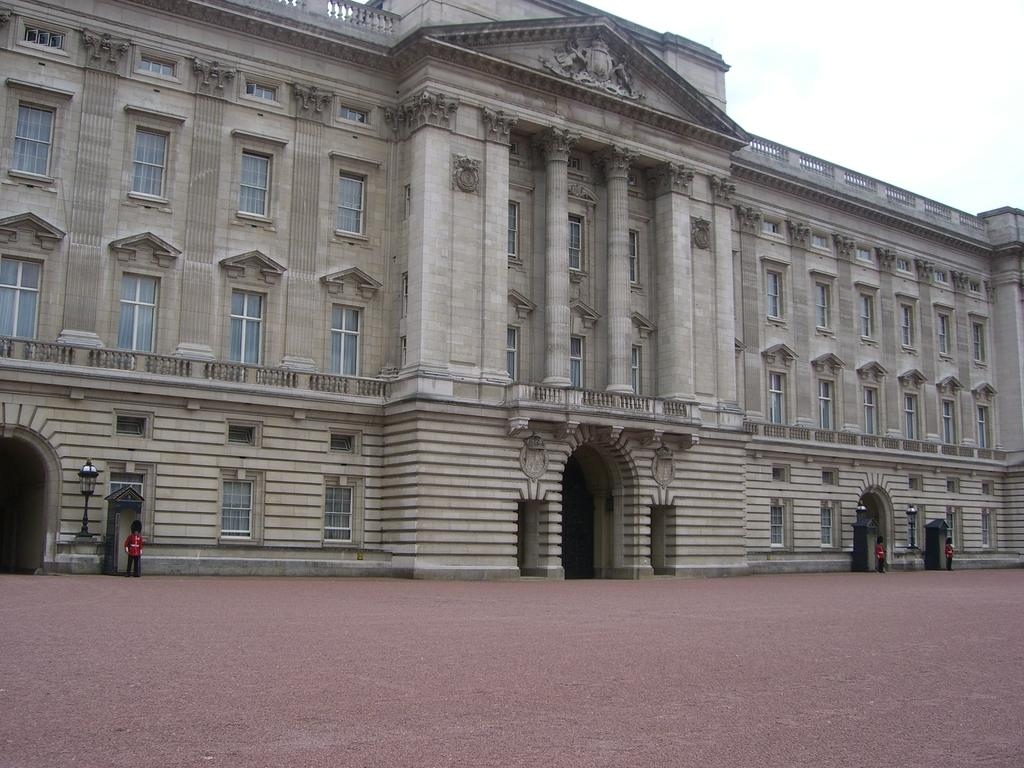What type of building is depicted in the image? There is a palace in the image. What can be seen in front of the palace? There are security guards in front of the palace. What type of ink is used to write the name of the nation on the palace walls? There is no mention of any ink or writing on the palace walls in the image. How many beds are visible in the image? There are no beds visible in the image. 